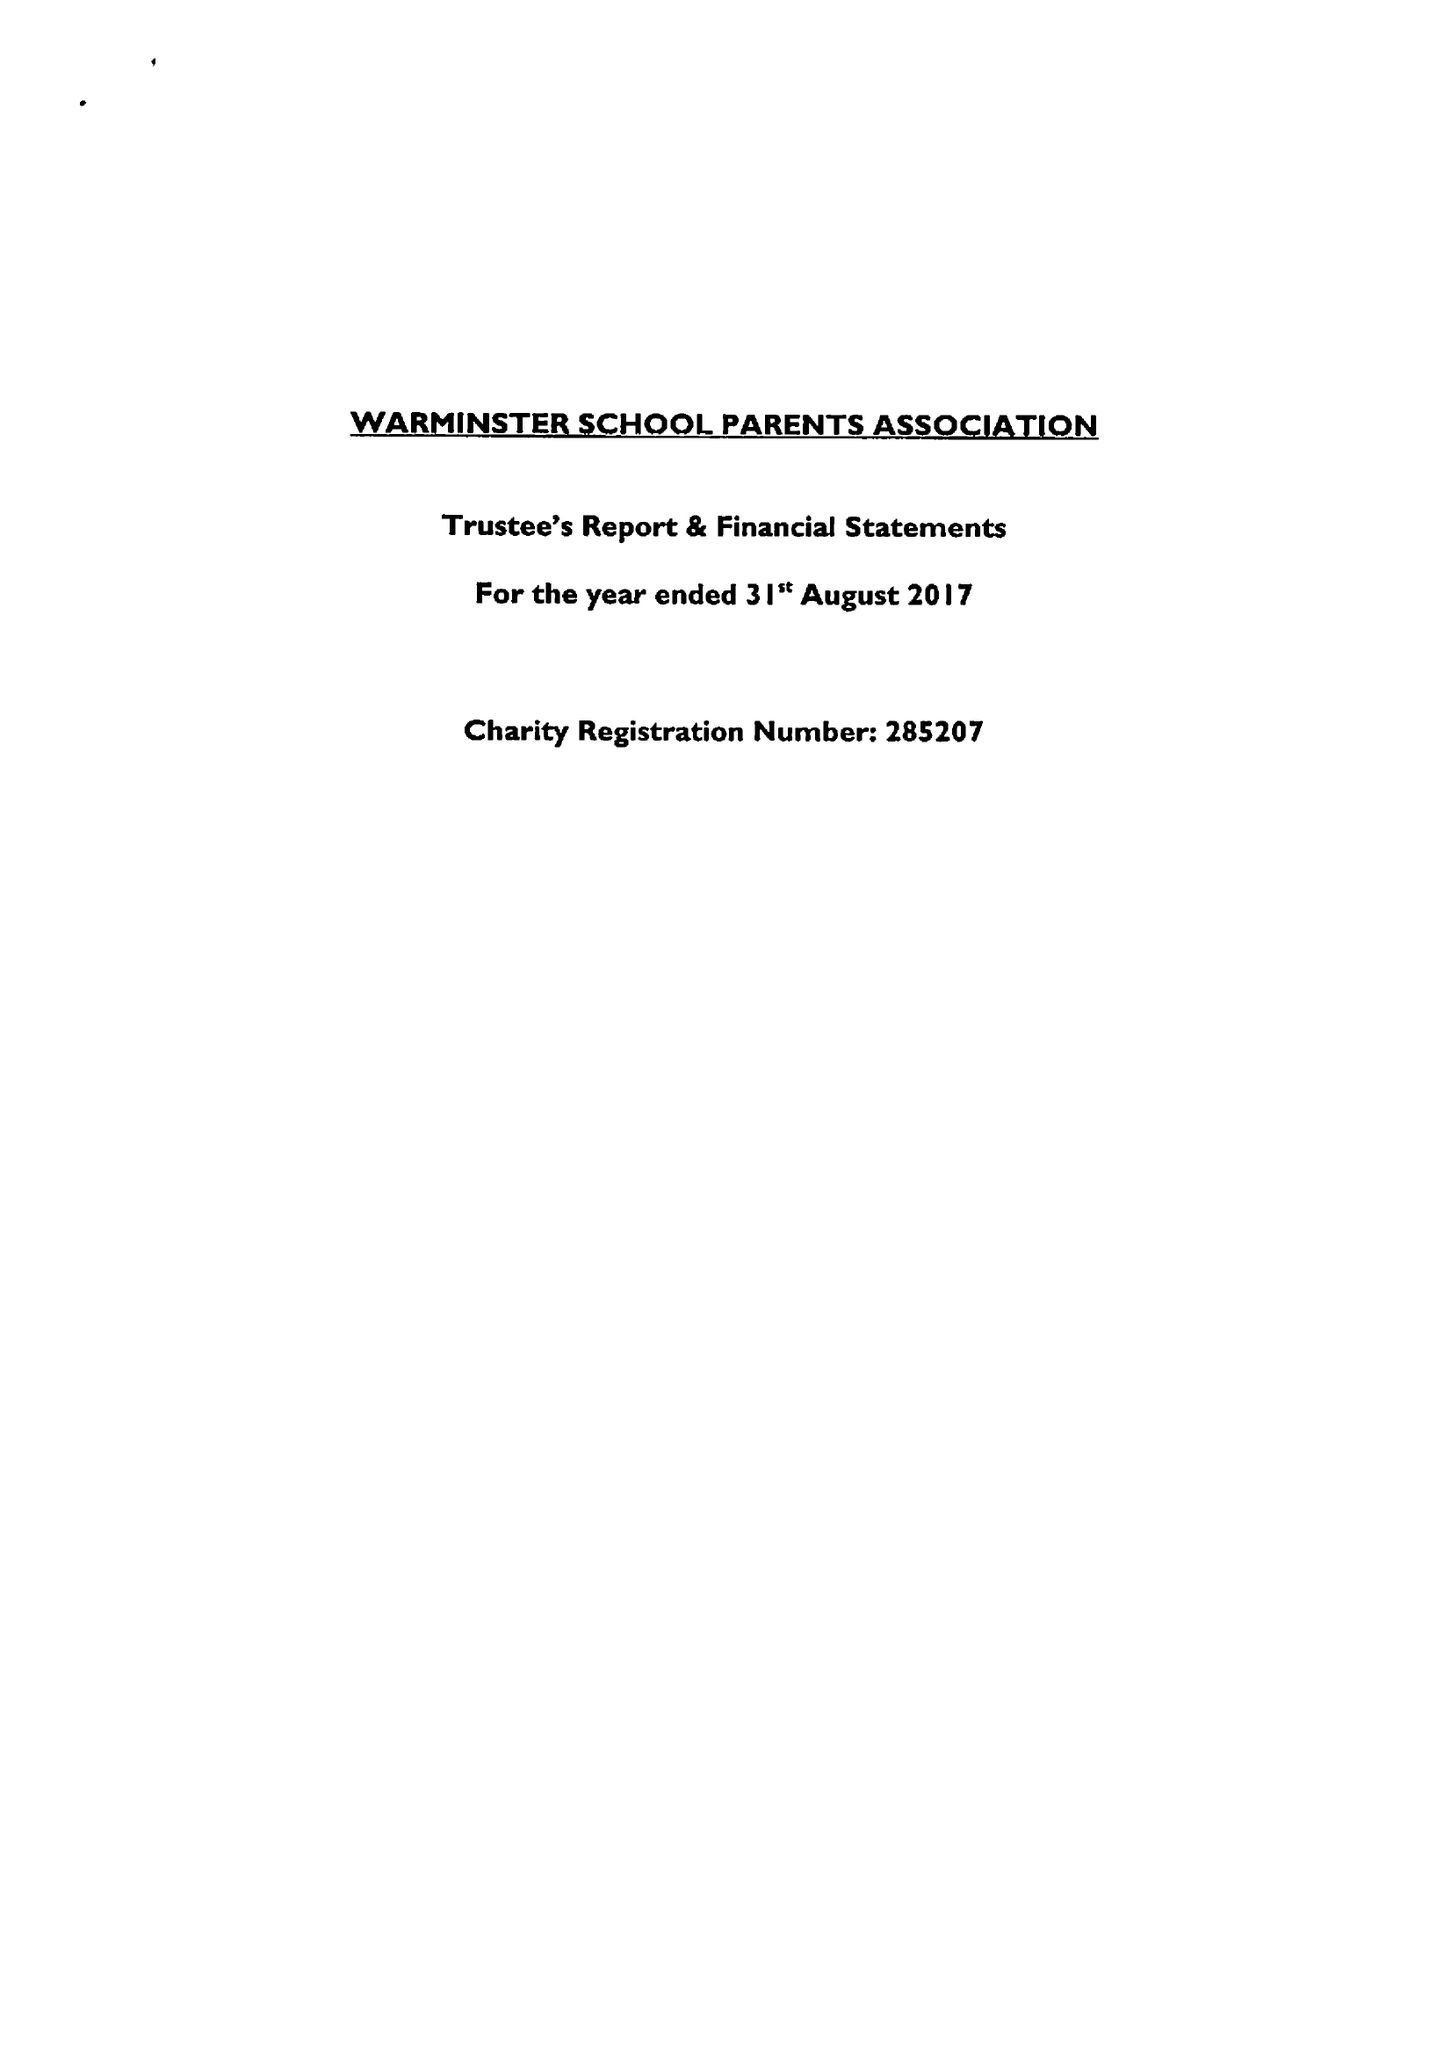What is the value for the address__post_town?
Answer the question using a single word or phrase. WARMINSTER 